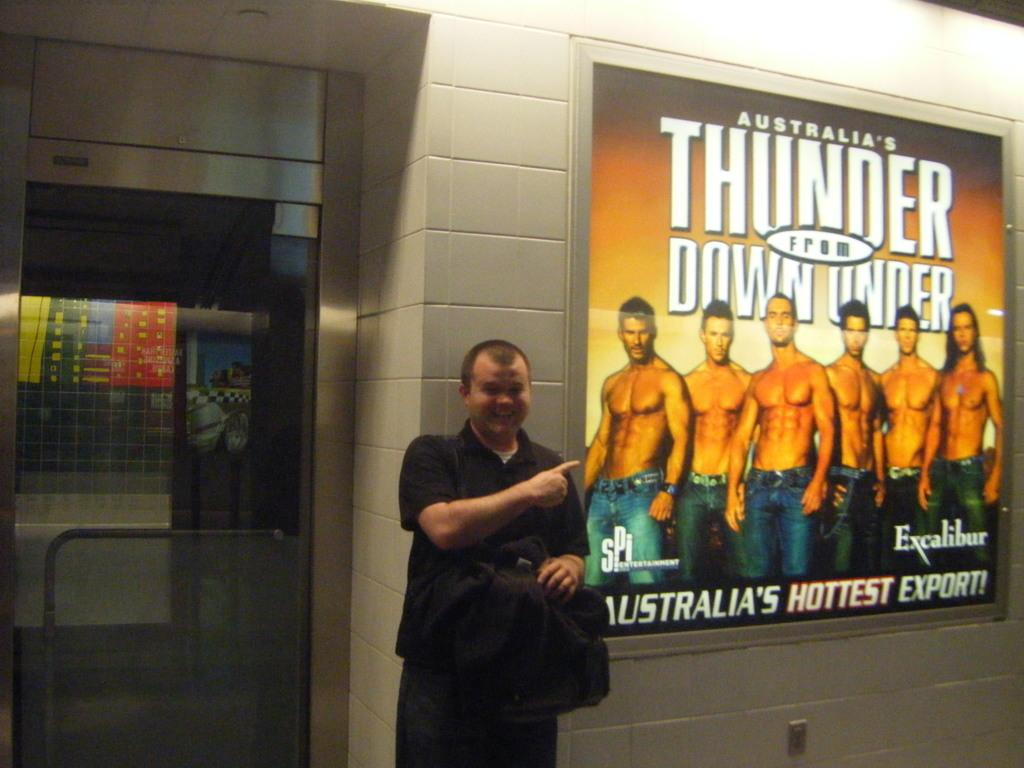What is the main subject of the image? There is a man standing in the center of the image. What is the man holding in his hand? The man is holding a cloth in his hand. What can be seen on the right side of the image? There is a board placed on the wall on the right side of the image. What is located on the left side of the image? There is a door on the left side of the image. How many cars can be seen in the image? There are no cars present in the image. What type of donkey is depicted on the board in the image? There is no donkey depicted on the board in the image; it is a board with unspecified content. 